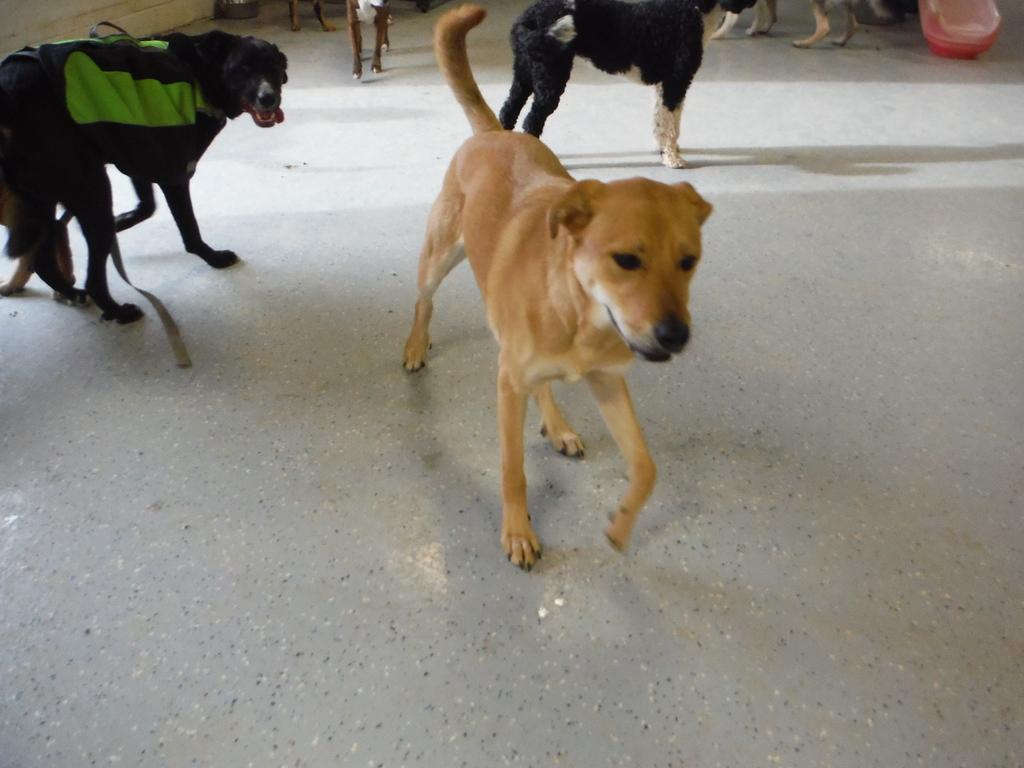What type of animals are in the image? There are dogs in the image. What are the dogs doing in the image? The dogs are standing. What type of dress is the dog wearing in the image? There is no dress present in the image, as dogs do not wear clothing. What is inside the drawer in the image? There is no drawer present in the image. 